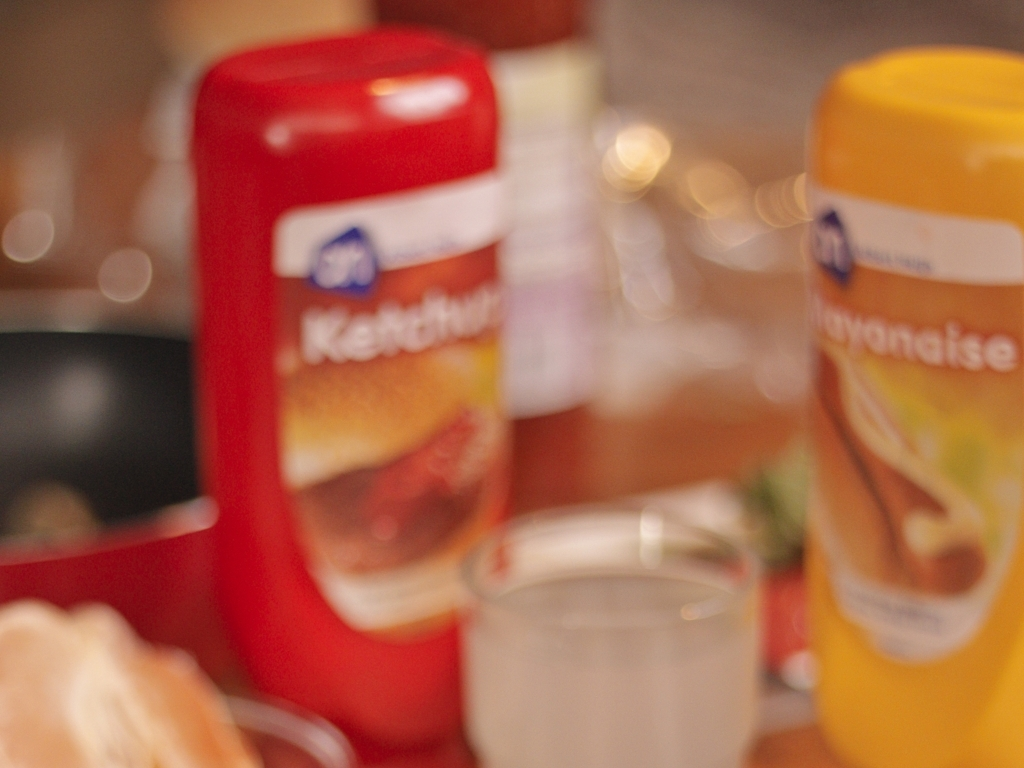What elements in the image can you identify, despite the blurriness? Despite the blurriness, it is possible to recognize that there are two bottles in the foreground, one labeled 'Ketchup' and the other 'Mayonnaise.' Additionally, a glass of a clear liquid, likely water, is discernible in the background. 